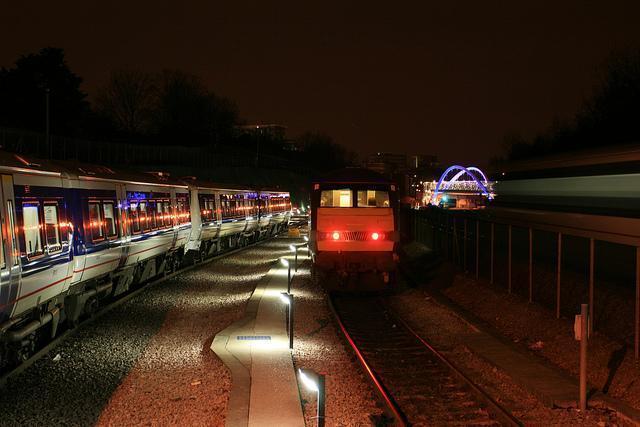How many trains do you see?
Give a very brief answer. 2. How many purple arcs are visible?
Give a very brief answer. 2. How many trains can you see?
Give a very brief answer. 2. How many elephants are there?
Give a very brief answer. 0. 